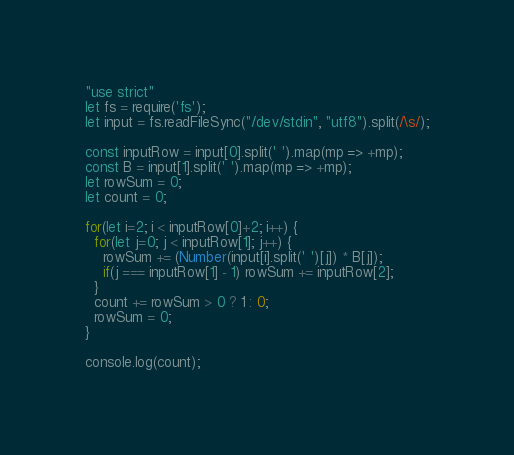<code> <loc_0><loc_0><loc_500><loc_500><_TypeScript_>
"use strict"
let fs = require('fs');
let input = fs.readFileSync("/dev/stdin", "utf8").split(/\s/);

const inputRow = input[0].split(' ').map(mp => +mp);
const B = input[1].split(' ').map(mp => +mp);  
let rowSum = 0;
let count = 0;

for(let i=2; i < inputRow[0]+2; i++) {
  for(let j=0; j < inputRow[1]; j++) {
    rowSum += (Number(input[i].split(' ')[j]) * B[j]);
    if(j === inputRow[1] - 1) rowSum += inputRow[2];
  }
  count += rowSum > 0 ? 1 : 0;
  rowSum = 0;
}

console.log(count);</code> 